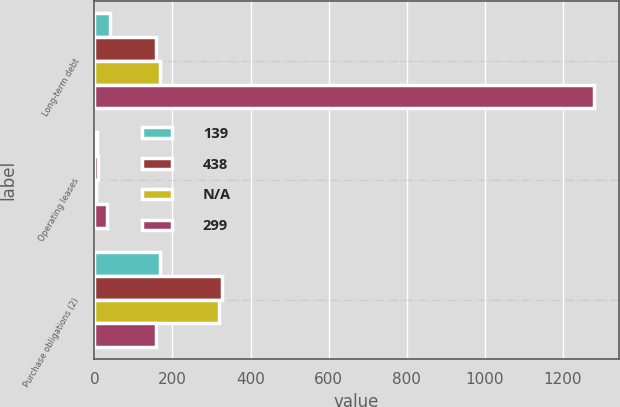Convert chart to OTSL. <chart><loc_0><loc_0><loc_500><loc_500><stacked_bar_chart><ecel><fcel>Long-term debt<fcel>Operating leases<fcel>Purchase obligations (2)<nl><fcel>139<fcel>40<fcel>6<fcel>167<nl><fcel>438<fcel>157<fcel>9<fcel>328<nl><fcel>nan<fcel>167<fcel>5<fcel>319<nl><fcel>299<fcel>1280<fcel>31<fcel>157<nl></chart> 